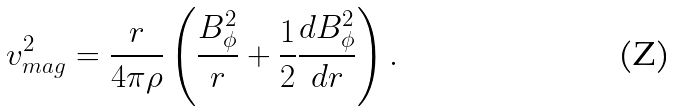Convert formula to latex. <formula><loc_0><loc_0><loc_500><loc_500>v _ { m a g } ^ { 2 } = \frac { r } { 4 \pi \rho } \left ( \frac { B _ { \phi } ^ { 2 } } { r } + \frac { 1 } { 2 } \frac { d B _ { \phi } ^ { 2 } } { d r } \right ) .</formula> 